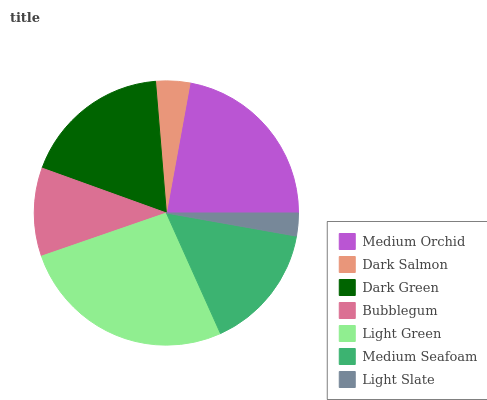Is Light Slate the minimum?
Answer yes or no. Yes. Is Light Green the maximum?
Answer yes or no. Yes. Is Dark Salmon the minimum?
Answer yes or no. No. Is Dark Salmon the maximum?
Answer yes or no. No. Is Medium Orchid greater than Dark Salmon?
Answer yes or no. Yes. Is Dark Salmon less than Medium Orchid?
Answer yes or no. Yes. Is Dark Salmon greater than Medium Orchid?
Answer yes or no. No. Is Medium Orchid less than Dark Salmon?
Answer yes or no. No. Is Medium Seafoam the high median?
Answer yes or no. Yes. Is Medium Seafoam the low median?
Answer yes or no. Yes. Is Medium Orchid the high median?
Answer yes or no. No. Is Medium Orchid the low median?
Answer yes or no. No. 